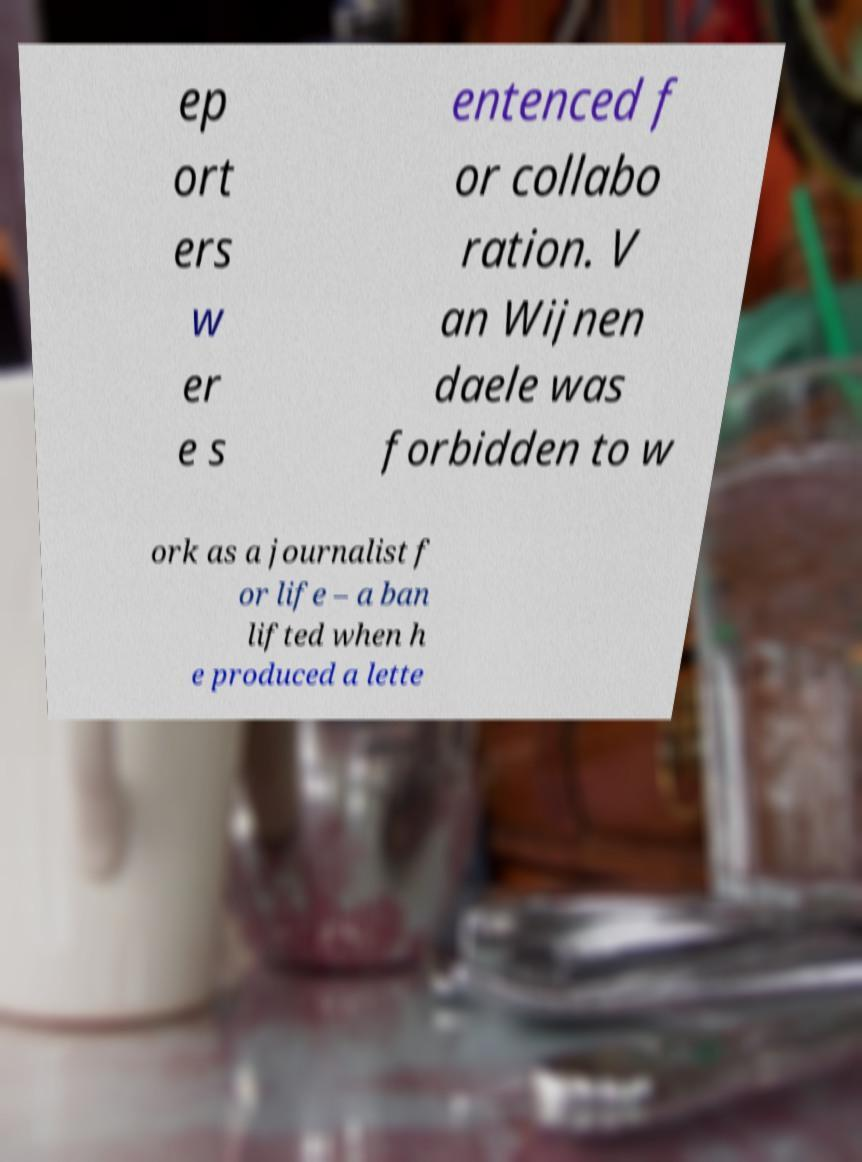Can you read and provide the text displayed in the image?This photo seems to have some interesting text. Can you extract and type it out for me? ep ort ers w er e s entenced f or collabo ration. V an Wijnen daele was forbidden to w ork as a journalist f or life – a ban lifted when h e produced a lette 